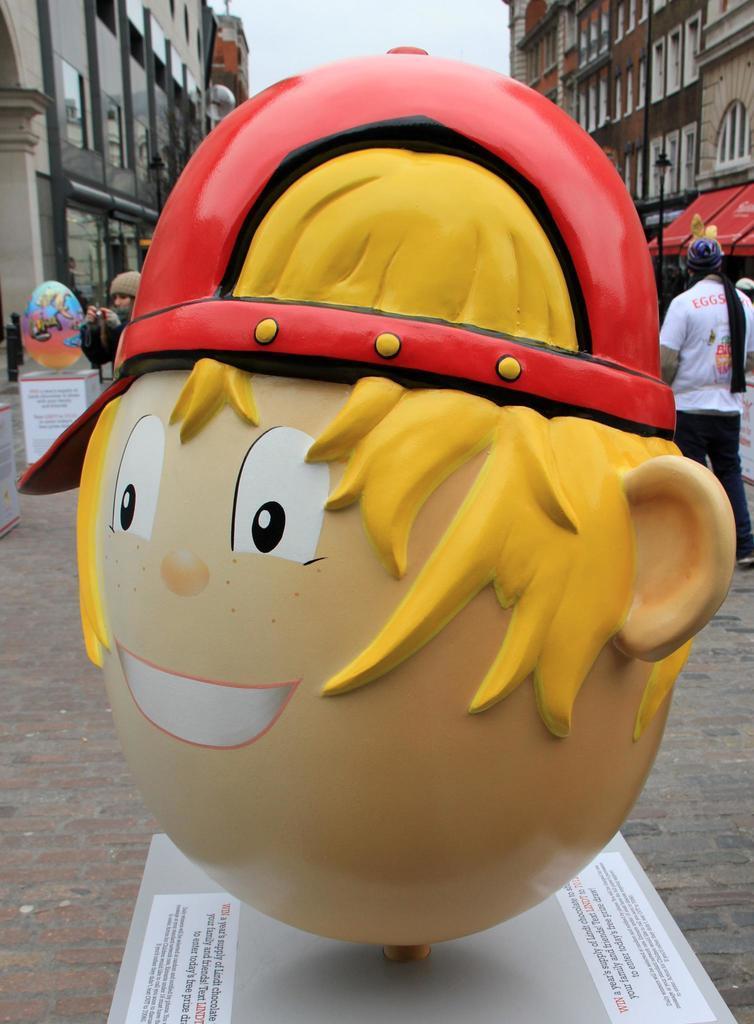Can you describe this image briefly? There is a mascot on a platform. On that something is written. In the back there are buildings, people and sky. 